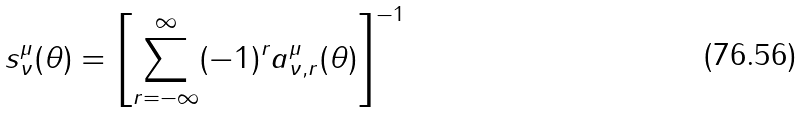<formula> <loc_0><loc_0><loc_500><loc_500>s ^ { \mu } _ { \nu } ( \theta ) = \left [ \sum _ { r = - \infty } ^ { \infty } ( - 1 ) ^ { r } a ^ { \mu } _ { \nu , r } ( \theta ) \right ] ^ { - 1 }</formula> 